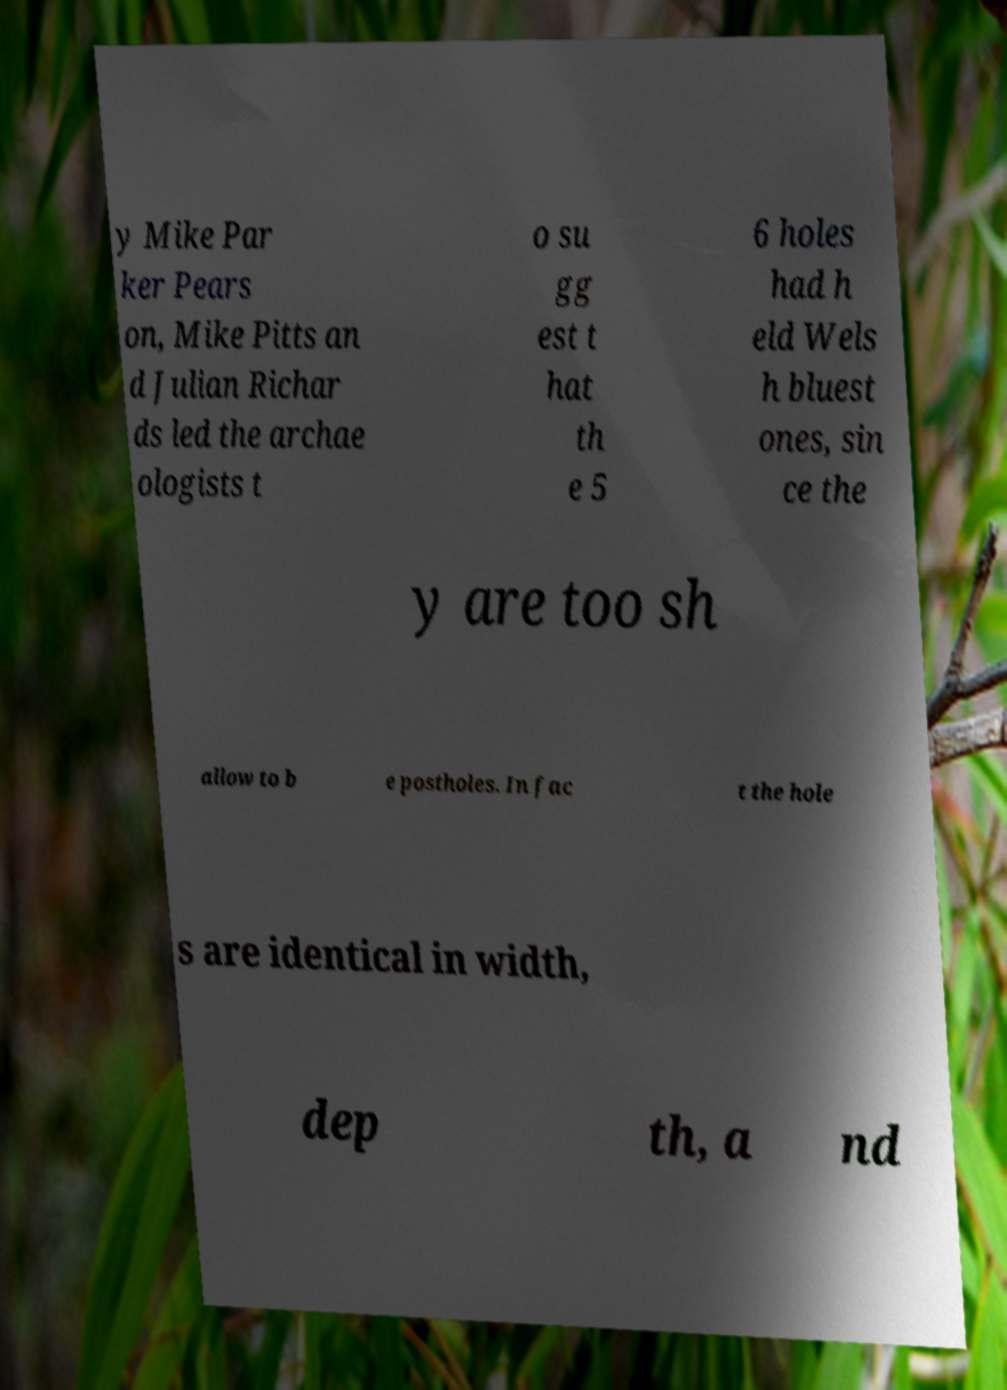What messages or text are displayed in this image? I need them in a readable, typed format. y Mike Par ker Pears on, Mike Pitts an d Julian Richar ds led the archae ologists t o su gg est t hat th e 5 6 holes had h eld Wels h bluest ones, sin ce the y are too sh allow to b e postholes. In fac t the hole s are identical in width, dep th, a nd 